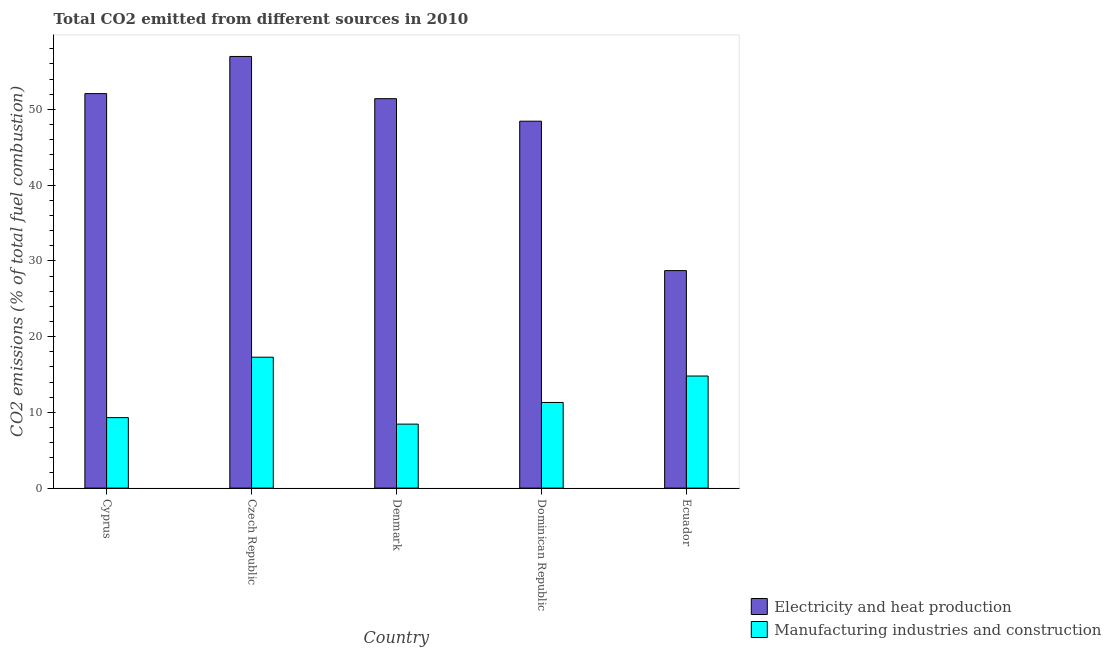How many groups of bars are there?
Provide a succinct answer. 5. Are the number of bars on each tick of the X-axis equal?
Offer a very short reply. Yes. How many bars are there on the 4th tick from the right?
Ensure brevity in your answer.  2. What is the label of the 2nd group of bars from the left?
Provide a short and direct response. Czech Republic. What is the co2 emissions due to electricity and heat production in Denmark?
Your answer should be very brief. 51.41. Across all countries, what is the maximum co2 emissions due to manufacturing industries?
Your response must be concise. 17.28. Across all countries, what is the minimum co2 emissions due to manufacturing industries?
Your answer should be compact. 8.45. In which country was the co2 emissions due to manufacturing industries maximum?
Your response must be concise. Czech Republic. In which country was the co2 emissions due to electricity and heat production minimum?
Give a very brief answer. Ecuador. What is the total co2 emissions due to electricity and heat production in the graph?
Make the answer very short. 237.64. What is the difference between the co2 emissions due to electricity and heat production in Czech Republic and that in Denmark?
Ensure brevity in your answer.  5.57. What is the difference between the co2 emissions due to electricity and heat production in Dominican Republic and the co2 emissions due to manufacturing industries in Czech Republic?
Your answer should be very brief. 31.16. What is the average co2 emissions due to electricity and heat production per country?
Your answer should be compact. 47.53. What is the difference between the co2 emissions due to manufacturing industries and co2 emissions due to electricity and heat production in Czech Republic?
Provide a succinct answer. -39.71. What is the ratio of the co2 emissions due to electricity and heat production in Czech Republic to that in Ecuador?
Make the answer very short. 1.98. Is the co2 emissions due to manufacturing industries in Czech Republic less than that in Dominican Republic?
Provide a short and direct response. No. What is the difference between the highest and the second highest co2 emissions due to electricity and heat production?
Provide a short and direct response. 4.9. What is the difference between the highest and the lowest co2 emissions due to electricity and heat production?
Keep it short and to the point. 28.27. Is the sum of the co2 emissions due to electricity and heat production in Dominican Republic and Ecuador greater than the maximum co2 emissions due to manufacturing industries across all countries?
Your response must be concise. Yes. What does the 1st bar from the left in Ecuador represents?
Your response must be concise. Electricity and heat production. What does the 2nd bar from the right in Denmark represents?
Provide a short and direct response. Electricity and heat production. Does the graph contain any zero values?
Provide a short and direct response. No. Does the graph contain grids?
Make the answer very short. No. How many legend labels are there?
Your answer should be compact. 2. What is the title of the graph?
Offer a terse response. Total CO2 emitted from different sources in 2010. What is the label or title of the X-axis?
Give a very brief answer. Country. What is the label or title of the Y-axis?
Give a very brief answer. CO2 emissions (% of total fuel combustion). What is the CO2 emissions (% of total fuel combustion) of Electricity and heat production in Cyprus?
Ensure brevity in your answer.  52.08. What is the CO2 emissions (% of total fuel combustion) of Manufacturing industries and construction in Cyprus?
Your answer should be very brief. 9.31. What is the CO2 emissions (% of total fuel combustion) in Electricity and heat production in Czech Republic?
Offer a terse response. 56.99. What is the CO2 emissions (% of total fuel combustion) of Manufacturing industries and construction in Czech Republic?
Provide a short and direct response. 17.28. What is the CO2 emissions (% of total fuel combustion) of Electricity and heat production in Denmark?
Offer a terse response. 51.41. What is the CO2 emissions (% of total fuel combustion) of Manufacturing industries and construction in Denmark?
Ensure brevity in your answer.  8.45. What is the CO2 emissions (% of total fuel combustion) of Electricity and heat production in Dominican Republic?
Provide a short and direct response. 48.44. What is the CO2 emissions (% of total fuel combustion) of Manufacturing industries and construction in Dominican Republic?
Offer a very short reply. 11.3. What is the CO2 emissions (% of total fuel combustion) of Electricity and heat production in Ecuador?
Ensure brevity in your answer.  28.71. What is the CO2 emissions (% of total fuel combustion) of Manufacturing industries and construction in Ecuador?
Offer a terse response. 14.8. Across all countries, what is the maximum CO2 emissions (% of total fuel combustion) in Electricity and heat production?
Your answer should be compact. 56.99. Across all countries, what is the maximum CO2 emissions (% of total fuel combustion) in Manufacturing industries and construction?
Provide a succinct answer. 17.28. Across all countries, what is the minimum CO2 emissions (% of total fuel combustion) of Electricity and heat production?
Make the answer very short. 28.71. Across all countries, what is the minimum CO2 emissions (% of total fuel combustion) in Manufacturing industries and construction?
Offer a terse response. 8.45. What is the total CO2 emissions (% of total fuel combustion) of Electricity and heat production in the graph?
Offer a terse response. 237.64. What is the total CO2 emissions (% of total fuel combustion) of Manufacturing industries and construction in the graph?
Make the answer very short. 61.13. What is the difference between the CO2 emissions (% of total fuel combustion) in Electricity and heat production in Cyprus and that in Czech Republic?
Give a very brief answer. -4.9. What is the difference between the CO2 emissions (% of total fuel combustion) in Manufacturing industries and construction in Cyprus and that in Czech Republic?
Make the answer very short. -7.98. What is the difference between the CO2 emissions (% of total fuel combustion) of Electricity and heat production in Cyprus and that in Denmark?
Your response must be concise. 0.67. What is the difference between the CO2 emissions (% of total fuel combustion) of Manufacturing industries and construction in Cyprus and that in Denmark?
Make the answer very short. 0.86. What is the difference between the CO2 emissions (% of total fuel combustion) of Electricity and heat production in Cyprus and that in Dominican Republic?
Your answer should be very brief. 3.64. What is the difference between the CO2 emissions (% of total fuel combustion) in Manufacturing industries and construction in Cyprus and that in Dominican Republic?
Keep it short and to the point. -2. What is the difference between the CO2 emissions (% of total fuel combustion) of Electricity and heat production in Cyprus and that in Ecuador?
Your answer should be very brief. 23.37. What is the difference between the CO2 emissions (% of total fuel combustion) of Manufacturing industries and construction in Cyprus and that in Ecuador?
Ensure brevity in your answer.  -5.49. What is the difference between the CO2 emissions (% of total fuel combustion) in Electricity and heat production in Czech Republic and that in Denmark?
Make the answer very short. 5.57. What is the difference between the CO2 emissions (% of total fuel combustion) of Manufacturing industries and construction in Czech Republic and that in Denmark?
Provide a short and direct response. 8.84. What is the difference between the CO2 emissions (% of total fuel combustion) of Electricity and heat production in Czech Republic and that in Dominican Republic?
Give a very brief answer. 8.55. What is the difference between the CO2 emissions (% of total fuel combustion) in Manufacturing industries and construction in Czech Republic and that in Dominican Republic?
Provide a succinct answer. 5.98. What is the difference between the CO2 emissions (% of total fuel combustion) in Electricity and heat production in Czech Republic and that in Ecuador?
Keep it short and to the point. 28.27. What is the difference between the CO2 emissions (% of total fuel combustion) of Manufacturing industries and construction in Czech Republic and that in Ecuador?
Your answer should be compact. 2.49. What is the difference between the CO2 emissions (% of total fuel combustion) of Electricity and heat production in Denmark and that in Dominican Republic?
Offer a terse response. 2.97. What is the difference between the CO2 emissions (% of total fuel combustion) in Manufacturing industries and construction in Denmark and that in Dominican Republic?
Provide a succinct answer. -2.86. What is the difference between the CO2 emissions (% of total fuel combustion) of Electricity and heat production in Denmark and that in Ecuador?
Your answer should be very brief. 22.7. What is the difference between the CO2 emissions (% of total fuel combustion) in Manufacturing industries and construction in Denmark and that in Ecuador?
Offer a very short reply. -6.35. What is the difference between the CO2 emissions (% of total fuel combustion) in Electricity and heat production in Dominican Republic and that in Ecuador?
Keep it short and to the point. 19.73. What is the difference between the CO2 emissions (% of total fuel combustion) of Manufacturing industries and construction in Dominican Republic and that in Ecuador?
Provide a short and direct response. -3.49. What is the difference between the CO2 emissions (% of total fuel combustion) of Electricity and heat production in Cyprus and the CO2 emissions (% of total fuel combustion) of Manufacturing industries and construction in Czech Republic?
Give a very brief answer. 34.8. What is the difference between the CO2 emissions (% of total fuel combustion) of Electricity and heat production in Cyprus and the CO2 emissions (% of total fuel combustion) of Manufacturing industries and construction in Denmark?
Offer a terse response. 43.64. What is the difference between the CO2 emissions (% of total fuel combustion) in Electricity and heat production in Cyprus and the CO2 emissions (% of total fuel combustion) in Manufacturing industries and construction in Dominican Republic?
Offer a terse response. 40.78. What is the difference between the CO2 emissions (% of total fuel combustion) in Electricity and heat production in Cyprus and the CO2 emissions (% of total fuel combustion) in Manufacturing industries and construction in Ecuador?
Keep it short and to the point. 37.29. What is the difference between the CO2 emissions (% of total fuel combustion) in Electricity and heat production in Czech Republic and the CO2 emissions (% of total fuel combustion) in Manufacturing industries and construction in Denmark?
Offer a terse response. 48.54. What is the difference between the CO2 emissions (% of total fuel combustion) of Electricity and heat production in Czech Republic and the CO2 emissions (% of total fuel combustion) of Manufacturing industries and construction in Dominican Republic?
Your answer should be very brief. 45.68. What is the difference between the CO2 emissions (% of total fuel combustion) of Electricity and heat production in Czech Republic and the CO2 emissions (% of total fuel combustion) of Manufacturing industries and construction in Ecuador?
Provide a succinct answer. 42.19. What is the difference between the CO2 emissions (% of total fuel combustion) of Electricity and heat production in Denmark and the CO2 emissions (% of total fuel combustion) of Manufacturing industries and construction in Dominican Republic?
Offer a terse response. 40.11. What is the difference between the CO2 emissions (% of total fuel combustion) in Electricity and heat production in Denmark and the CO2 emissions (% of total fuel combustion) in Manufacturing industries and construction in Ecuador?
Offer a very short reply. 36.62. What is the difference between the CO2 emissions (% of total fuel combustion) of Electricity and heat production in Dominican Republic and the CO2 emissions (% of total fuel combustion) of Manufacturing industries and construction in Ecuador?
Your answer should be very brief. 33.65. What is the average CO2 emissions (% of total fuel combustion) in Electricity and heat production per country?
Give a very brief answer. 47.53. What is the average CO2 emissions (% of total fuel combustion) in Manufacturing industries and construction per country?
Make the answer very short. 12.23. What is the difference between the CO2 emissions (% of total fuel combustion) of Electricity and heat production and CO2 emissions (% of total fuel combustion) of Manufacturing industries and construction in Cyprus?
Make the answer very short. 42.78. What is the difference between the CO2 emissions (% of total fuel combustion) in Electricity and heat production and CO2 emissions (% of total fuel combustion) in Manufacturing industries and construction in Czech Republic?
Provide a succinct answer. 39.71. What is the difference between the CO2 emissions (% of total fuel combustion) of Electricity and heat production and CO2 emissions (% of total fuel combustion) of Manufacturing industries and construction in Denmark?
Offer a very short reply. 42.97. What is the difference between the CO2 emissions (% of total fuel combustion) in Electricity and heat production and CO2 emissions (% of total fuel combustion) in Manufacturing industries and construction in Dominican Republic?
Offer a terse response. 37.14. What is the difference between the CO2 emissions (% of total fuel combustion) in Electricity and heat production and CO2 emissions (% of total fuel combustion) in Manufacturing industries and construction in Ecuador?
Offer a very short reply. 13.92. What is the ratio of the CO2 emissions (% of total fuel combustion) in Electricity and heat production in Cyprus to that in Czech Republic?
Ensure brevity in your answer.  0.91. What is the ratio of the CO2 emissions (% of total fuel combustion) in Manufacturing industries and construction in Cyprus to that in Czech Republic?
Offer a terse response. 0.54. What is the ratio of the CO2 emissions (% of total fuel combustion) of Manufacturing industries and construction in Cyprus to that in Denmark?
Keep it short and to the point. 1.1. What is the ratio of the CO2 emissions (% of total fuel combustion) in Electricity and heat production in Cyprus to that in Dominican Republic?
Make the answer very short. 1.08. What is the ratio of the CO2 emissions (% of total fuel combustion) in Manufacturing industries and construction in Cyprus to that in Dominican Republic?
Provide a succinct answer. 0.82. What is the ratio of the CO2 emissions (% of total fuel combustion) in Electricity and heat production in Cyprus to that in Ecuador?
Give a very brief answer. 1.81. What is the ratio of the CO2 emissions (% of total fuel combustion) in Manufacturing industries and construction in Cyprus to that in Ecuador?
Your response must be concise. 0.63. What is the ratio of the CO2 emissions (% of total fuel combustion) in Electricity and heat production in Czech Republic to that in Denmark?
Ensure brevity in your answer.  1.11. What is the ratio of the CO2 emissions (% of total fuel combustion) in Manufacturing industries and construction in Czech Republic to that in Denmark?
Offer a terse response. 2.05. What is the ratio of the CO2 emissions (% of total fuel combustion) of Electricity and heat production in Czech Republic to that in Dominican Republic?
Ensure brevity in your answer.  1.18. What is the ratio of the CO2 emissions (% of total fuel combustion) in Manufacturing industries and construction in Czech Republic to that in Dominican Republic?
Offer a very short reply. 1.53. What is the ratio of the CO2 emissions (% of total fuel combustion) of Electricity and heat production in Czech Republic to that in Ecuador?
Ensure brevity in your answer.  1.98. What is the ratio of the CO2 emissions (% of total fuel combustion) of Manufacturing industries and construction in Czech Republic to that in Ecuador?
Offer a terse response. 1.17. What is the ratio of the CO2 emissions (% of total fuel combustion) of Electricity and heat production in Denmark to that in Dominican Republic?
Give a very brief answer. 1.06. What is the ratio of the CO2 emissions (% of total fuel combustion) in Manufacturing industries and construction in Denmark to that in Dominican Republic?
Provide a succinct answer. 0.75. What is the ratio of the CO2 emissions (% of total fuel combustion) of Electricity and heat production in Denmark to that in Ecuador?
Your response must be concise. 1.79. What is the ratio of the CO2 emissions (% of total fuel combustion) of Manufacturing industries and construction in Denmark to that in Ecuador?
Give a very brief answer. 0.57. What is the ratio of the CO2 emissions (% of total fuel combustion) of Electricity and heat production in Dominican Republic to that in Ecuador?
Ensure brevity in your answer.  1.69. What is the ratio of the CO2 emissions (% of total fuel combustion) in Manufacturing industries and construction in Dominican Republic to that in Ecuador?
Make the answer very short. 0.76. What is the difference between the highest and the second highest CO2 emissions (% of total fuel combustion) of Electricity and heat production?
Your answer should be compact. 4.9. What is the difference between the highest and the second highest CO2 emissions (% of total fuel combustion) in Manufacturing industries and construction?
Your answer should be compact. 2.49. What is the difference between the highest and the lowest CO2 emissions (% of total fuel combustion) of Electricity and heat production?
Offer a terse response. 28.27. What is the difference between the highest and the lowest CO2 emissions (% of total fuel combustion) in Manufacturing industries and construction?
Provide a short and direct response. 8.84. 